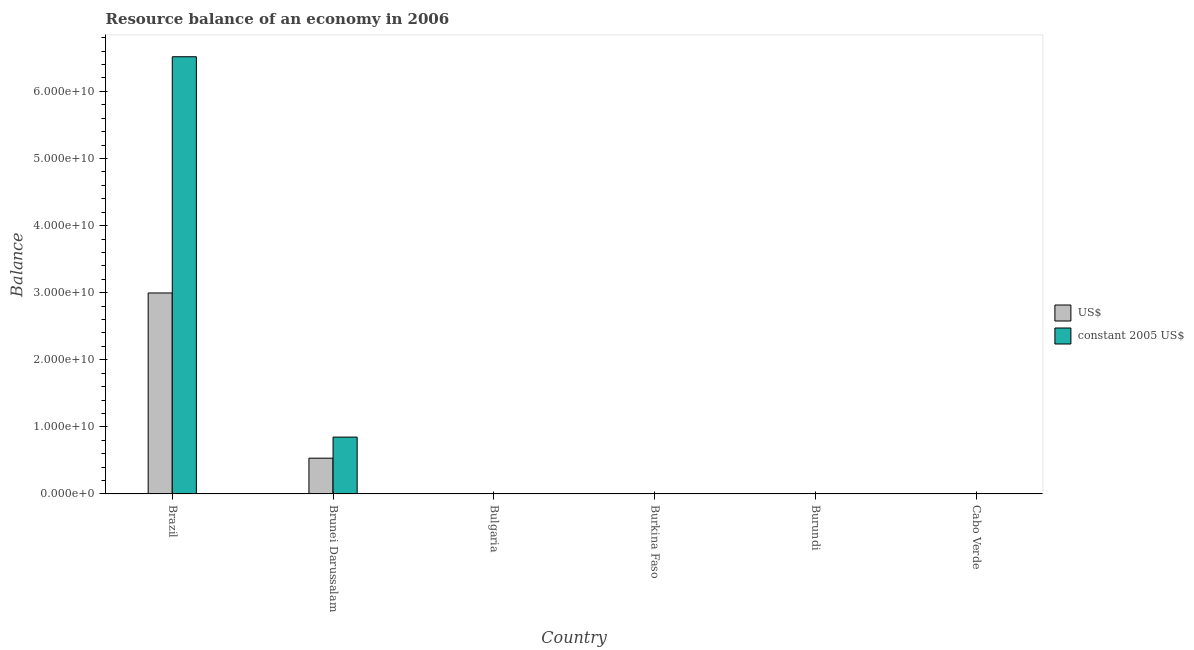How many different coloured bars are there?
Offer a very short reply. 2. Are the number of bars on each tick of the X-axis equal?
Offer a terse response. No. How many bars are there on the 5th tick from the left?
Ensure brevity in your answer.  0. What is the resource balance in us$ in Bulgaria?
Provide a short and direct response. 0. Across all countries, what is the maximum resource balance in constant us$?
Provide a short and direct response. 6.52e+1. Across all countries, what is the minimum resource balance in us$?
Ensure brevity in your answer.  0. What is the total resource balance in constant us$ in the graph?
Offer a terse response. 7.36e+1. What is the difference between the resource balance in constant us$ in Bulgaria and the resource balance in us$ in Cabo Verde?
Your answer should be compact. 0. What is the average resource balance in constant us$ per country?
Make the answer very short. 1.23e+1. What is the difference between the resource balance in us$ and resource balance in constant us$ in Brunei Darussalam?
Provide a short and direct response. -3.14e+09. What is the ratio of the resource balance in constant us$ in Brazil to that in Brunei Darussalam?
Ensure brevity in your answer.  7.69. What is the difference between the highest and the lowest resource balance in us$?
Keep it short and to the point. 3.00e+1. In how many countries, is the resource balance in us$ greater than the average resource balance in us$ taken over all countries?
Provide a short and direct response. 1. Are all the bars in the graph horizontal?
Your answer should be compact. No. What is the difference between two consecutive major ticks on the Y-axis?
Keep it short and to the point. 1.00e+1. Does the graph contain any zero values?
Ensure brevity in your answer.  Yes. Does the graph contain grids?
Make the answer very short. No. Where does the legend appear in the graph?
Provide a short and direct response. Center right. How many legend labels are there?
Your answer should be very brief. 2. What is the title of the graph?
Your answer should be compact. Resource balance of an economy in 2006. Does "Overweight" appear as one of the legend labels in the graph?
Make the answer very short. No. What is the label or title of the Y-axis?
Keep it short and to the point. Balance. What is the Balance in US$ in Brazil?
Offer a terse response. 3.00e+1. What is the Balance in constant 2005 US$ in Brazil?
Offer a very short reply. 6.52e+1. What is the Balance in US$ in Brunei Darussalam?
Provide a succinct answer. 5.33e+09. What is the Balance of constant 2005 US$ in Brunei Darussalam?
Provide a short and direct response. 8.48e+09. What is the Balance in constant 2005 US$ in Bulgaria?
Make the answer very short. 0. What is the Balance of US$ in Burkina Faso?
Provide a succinct answer. 0. What is the Balance in US$ in Burundi?
Offer a terse response. 0. What is the Balance of constant 2005 US$ in Burundi?
Make the answer very short. 0. What is the Balance of US$ in Cabo Verde?
Ensure brevity in your answer.  0. What is the Balance of constant 2005 US$ in Cabo Verde?
Provide a succinct answer. 0. Across all countries, what is the maximum Balance in US$?
Offer a very short reply. 3.00e+1. Across all countries, what is the maximum Balance of constant 2005 US$?
Offer a terse response. 6.52e+1. Across all countries, what is the minimum Balance of constant 2005 US$?
Make the answer very short. 0. What is the total Balance in US$ in the graph?
Ensure brevity in your answer.  3.53e+1. What is the total Balance of constant 2005 US$ in the graph?
Your answer should be very brief. 7.36e+1. What is the difference between the Balance in US$ in Brazil and that in Brunei Darussalam?
Keep it short and to the point. 2.46e+1. What is the difference between the Balance in constant 2005 US$ in Brazil and that in Brunei Darussalam?
Make the answer very short. 5.67e+1. What is the difference between the Balance of US$ in Brazil and the Balance of constant 2005 US$ in Brunei Darussalam?
Your answer should be very brief. 2.15e+1. What is the average Balance in US$ per country?
Offer a terse response. 5.88e+09. What is the average Balance in constant 2005 US$ per country?
Provide a succinct answer. 1.23e+1. What is the difference between the Balance in US$ and Balance in constant 2005 US$ in Brazil?
Offer a terse response. -3.52e+1. What is the difference between the Balance of US$ and Balance of constant 2005 US$ in Brunei Darussalam?
Make the answer very short. -3.14e+09. What is the ratio of the Balance of US$ in Brazil to that in Brunei Darussalam?
Provide a succinct answer. 5.62. What is the ratio of the Balance of constant 2005 US$ in Brazil to that in Brunei Darussalam?
Give a very brief answer. 7.69. What is the difference between the highest and the lowest Balance of US$?
Offer a terse response. 3.00e+1. What is the difference between the highest and the lowest Balance in constant 2005 US$?
Your answer should be compact. 6.52e+1. 